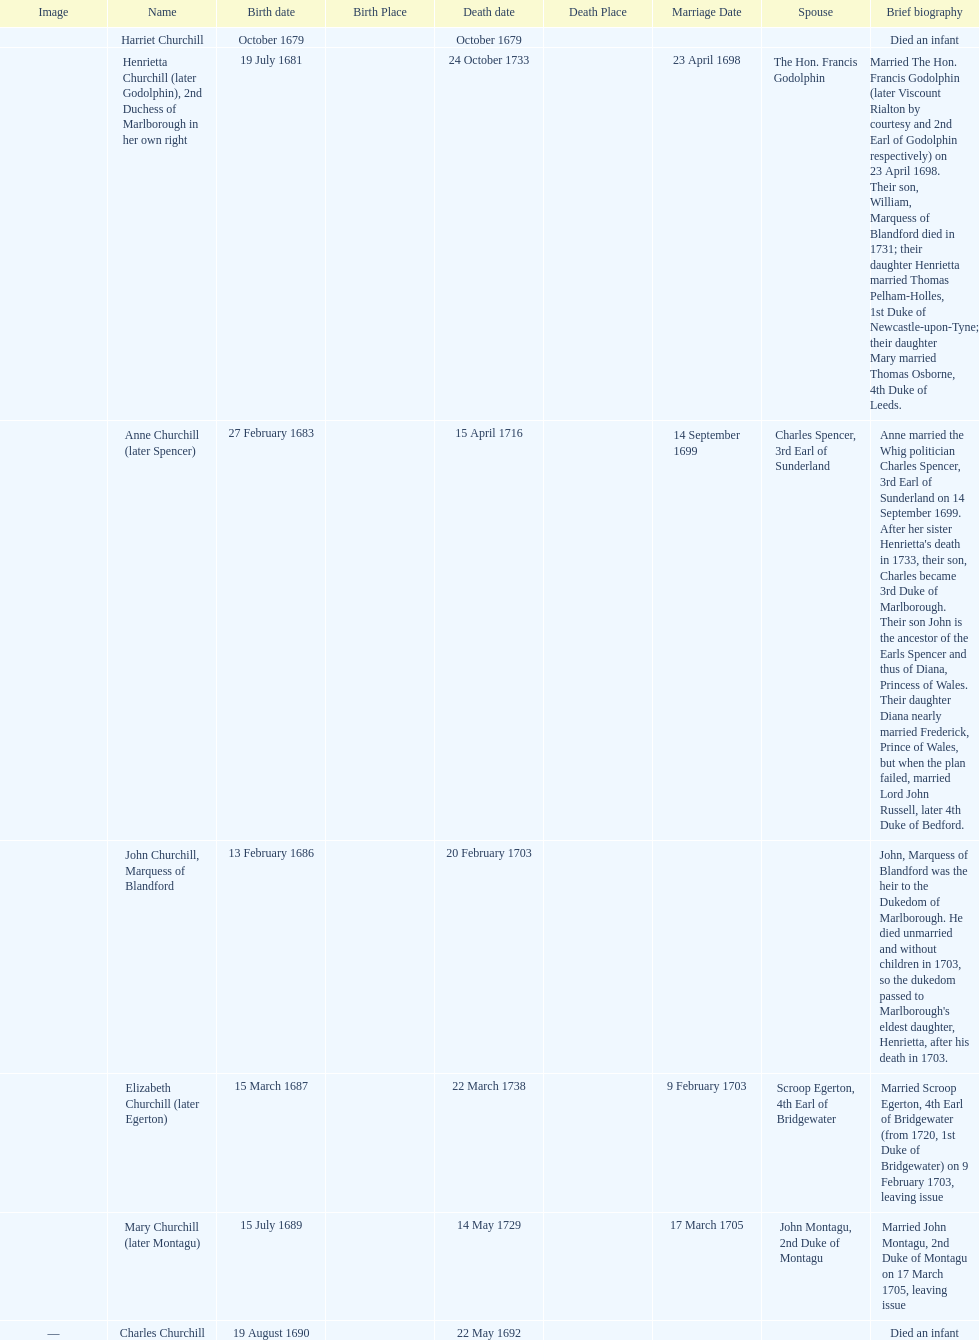Which child was born after elizabeth churchill? Mary Churchill. 